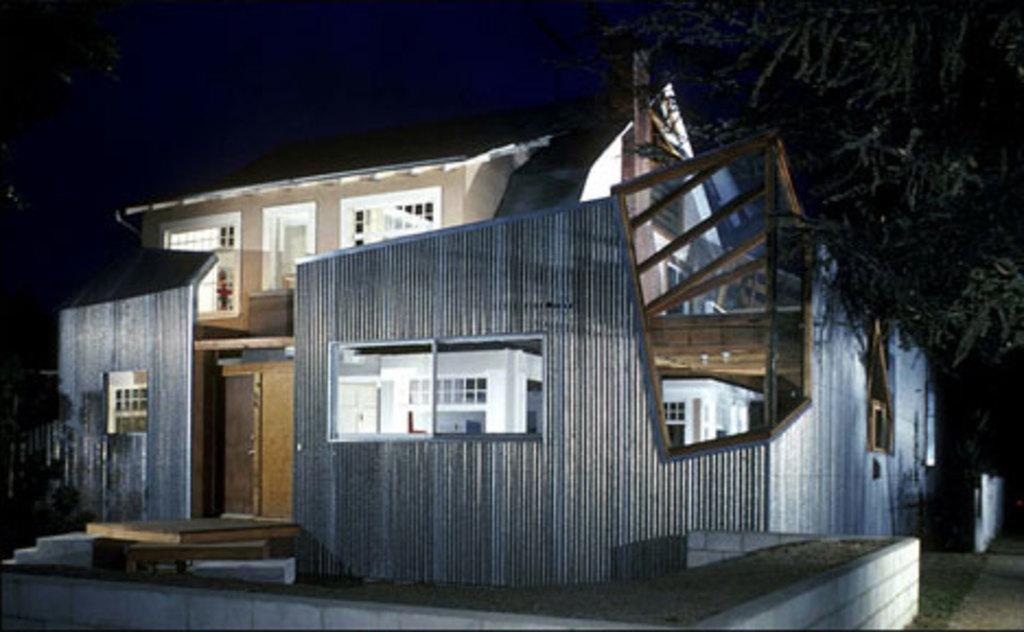How would you summarize this image in a sentence or two? This picture is clicked outside. In the foreground we can see the stairs, bench and some objects. In the center we can see the building and we can see some wooden objects. On the right we can see the tree. In the background we can see the sky. In the left corner we can see the green leaves. 